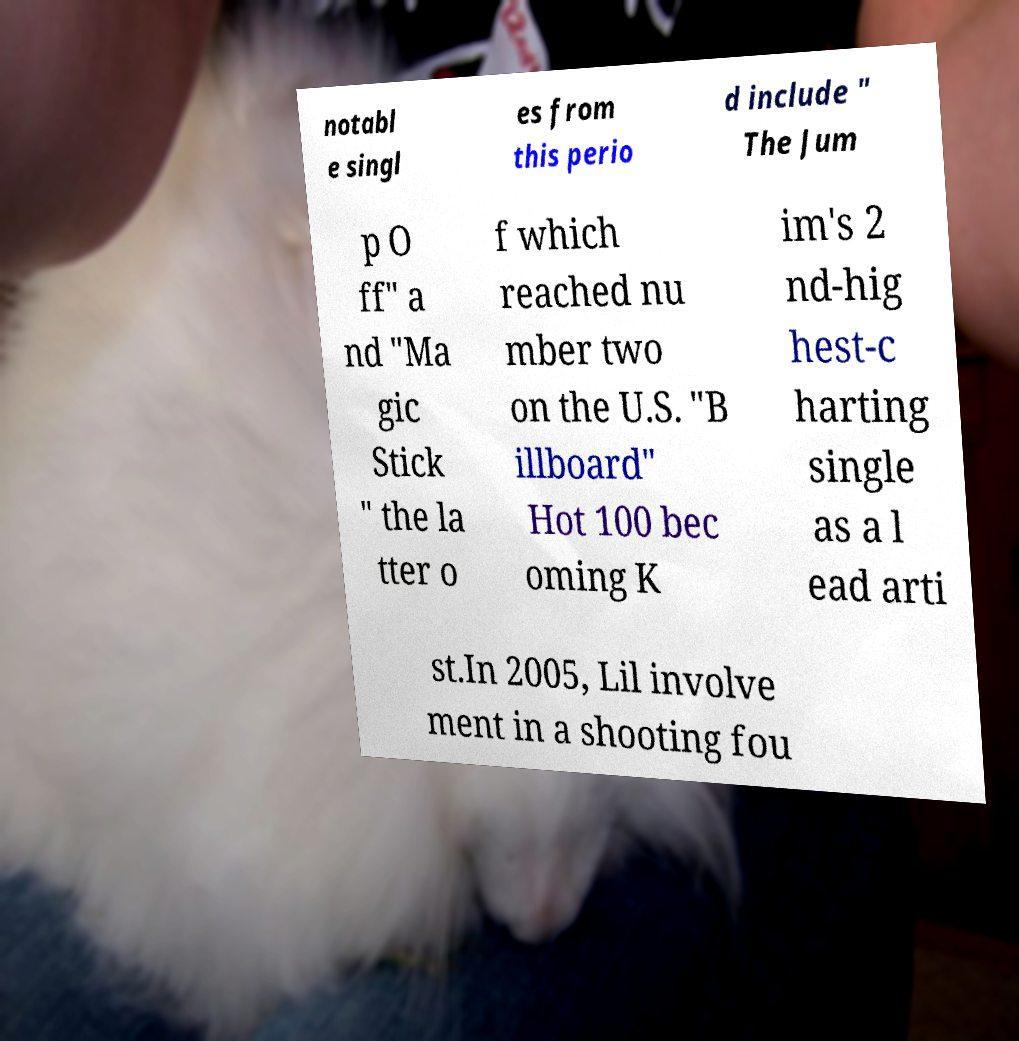Can you accurately transcribe the text from the provided image for me? notabl e singl es from this perio d include " The Jum p O ff" a nd "Ma gic Stick " the la tter o f which reached nu mber two on the U.S. "B illboard" Hot 100 bec oming K im's 2 nd-hig hest-c harting single as a l ead arti st.In 2005, Lil involve ment in a shooting fou 